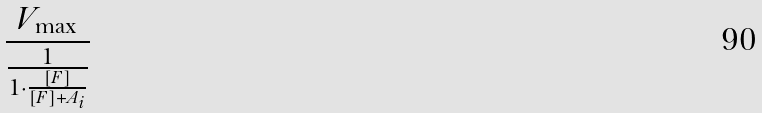<formula> <loc_0><loc_0><loc_500><loc_500>\frac { V _ { \max } } { \frac { 1 } { 1 \cdot \frac { [ F ] } { [ F ] + A _ { i } } } }</formula> 